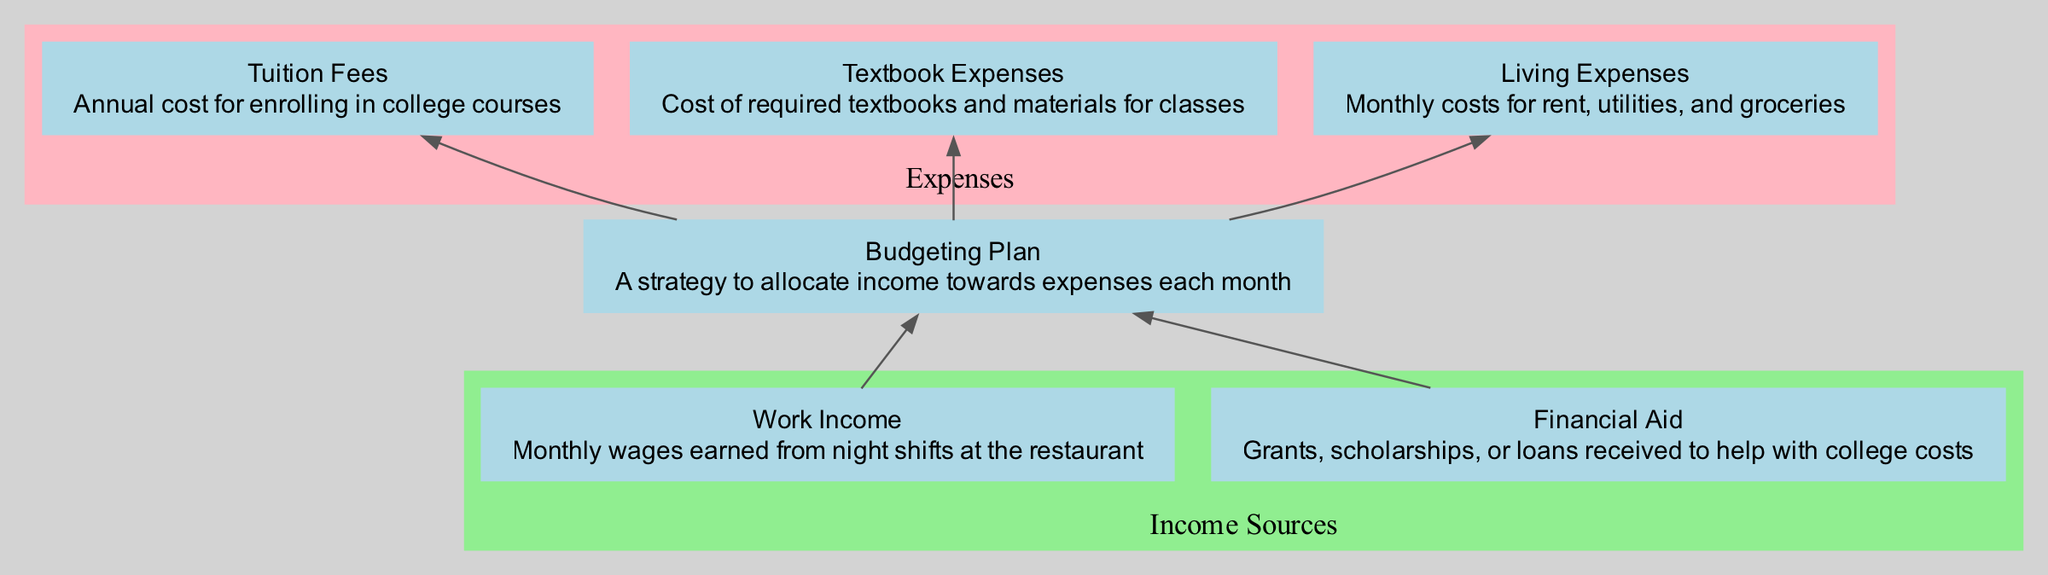What are the income sources in the diagram? The diagram lists "Work Income" and "Financial Aid" as the income sources under the "Income Sources" subgraph.
Answer: Work Income, Financial Aid How many expenses are represented in the flow chart? The flow chart shows three expenses: "Tuition Fees", "Textbook Expenses", and "Living Expenses", which are all located in the "Expenses" subgraph.
Answer: Three What is the flow relationship between "Budgeting Plan" and "Tuition Fees"? The "Budgeting Plan" directs towards "Tuition Fees", indicating that the budgeting strategy is allocated for this expense.
Answer: Allocated What is the main function of the "Budgeting Plan"? The flow chart illustrates that the "Budgeting Plan" organizes income sources into allocations for various expenses, including tuition, textbooks, and living costs.
Answer: Organizes income Which node does "Financial Aid" connect to in the flow chart? From the diagram, "Financial Aid" directly connects to the "Budgeting Plan", indicating that it contributes as input to the budgeting process.
Answer: Budgeting Plan What will be the result if the "Budgeting Plan" does not include "Living Expenses"? If "Living Expenses" are not included, the budgeting plan would be incomplete as it wouldn't address essential monthly costs for rent, utilities, and groceries, which affects overall budgeting effectiveness.
Answer: Incomplete budgeting How many total nodes are in the diagram? The diagram has six nodes: "Work Income", "Financial Aid", "Budgeting Plan", "Tuition Fees", "Textbook Expenses", and "Living Expenses".
Answer: Six What type of flow chart is represented here? The flow chart specifically depicts a "Bottom Up Flow Chart" which emphasizes how income sources support the budgeting plan and its resulting expenses.
Answer: Bottom Up Flow Chart 